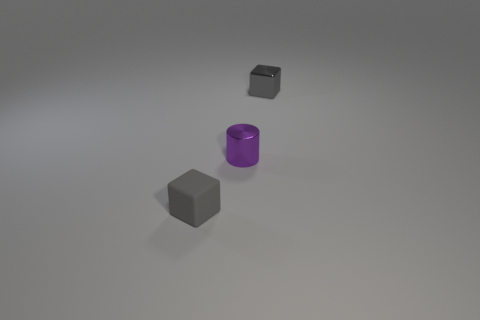Add 2 big brown rubber objects. How many objects exist? 5 Subtract all blocks. How many objects are left? 1 Subtract all small gray things. Subtract all cyan cubes. How many objects are left? 1 Add 3 cylinders. How many cylinders are left? 4 Add 2 cyan matte balls. How many cyan matte balls exist? 2 Subtract 0 gray cylinders. How many objects are left? 3 